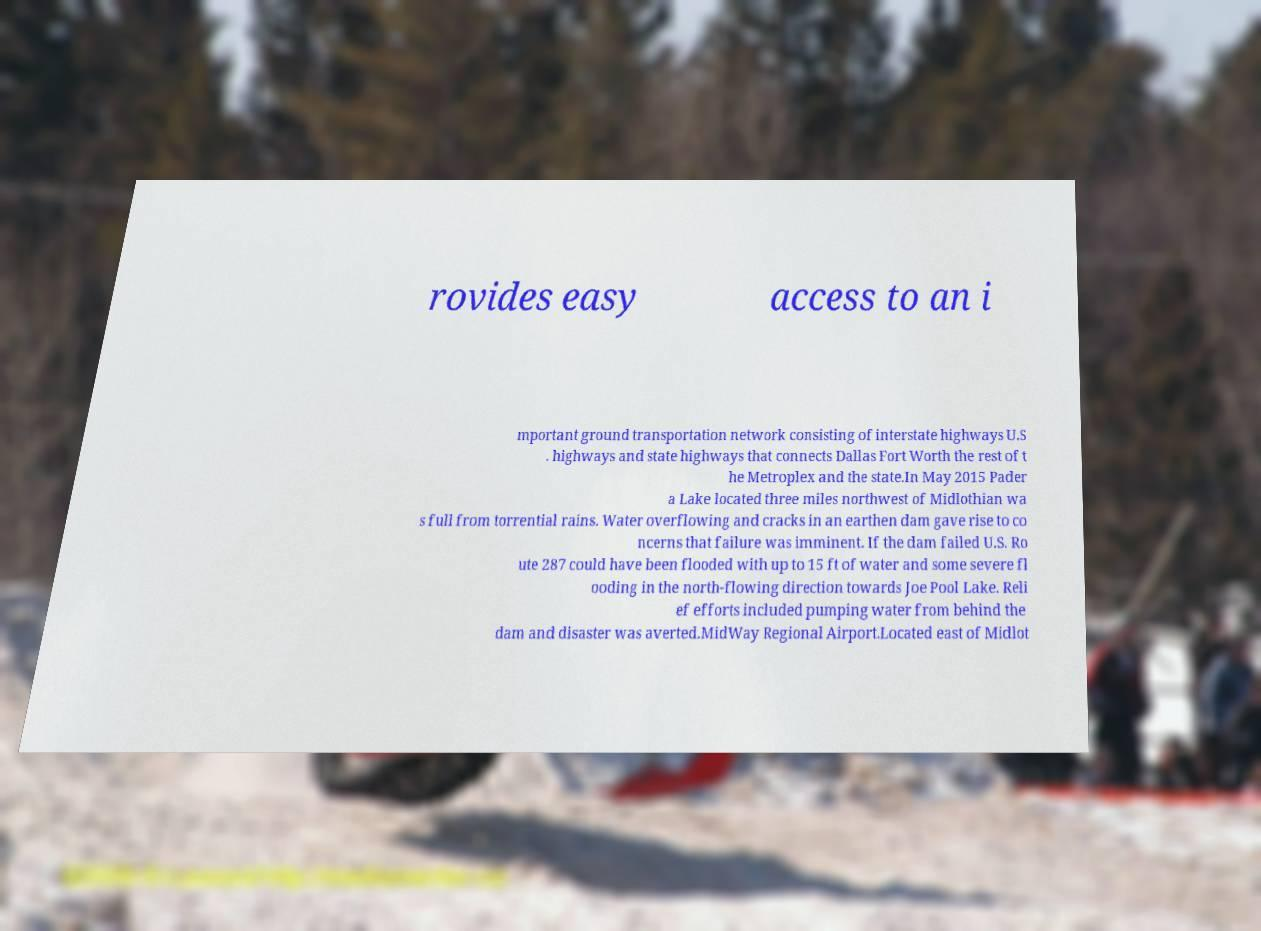Can you accurately transcribe the text from the provided image for me? rovides easy access to an i mportant ground transportation network consisting of interstate highways U.S . highways and state highways that connects Dallas Fort Worth the rest of t he Metroplex and the state.In May 2015 Pader a Lake located three miles northwest of Midlothian wa s full from torrential rains. Water overflowing and cracks in an earthen dam gave rise to co ncerns that failure was imminent. If the dam failed U.S. Ro ute 287 could have been flooded with up to 15 ft of water and some severe fl ooding in the north-flowing direction towards Joe Pool Lake. Reli ef efforts included pumping water from behind the dam and disaster was averted.MidWay Regional Airport.Located east of Midlot 